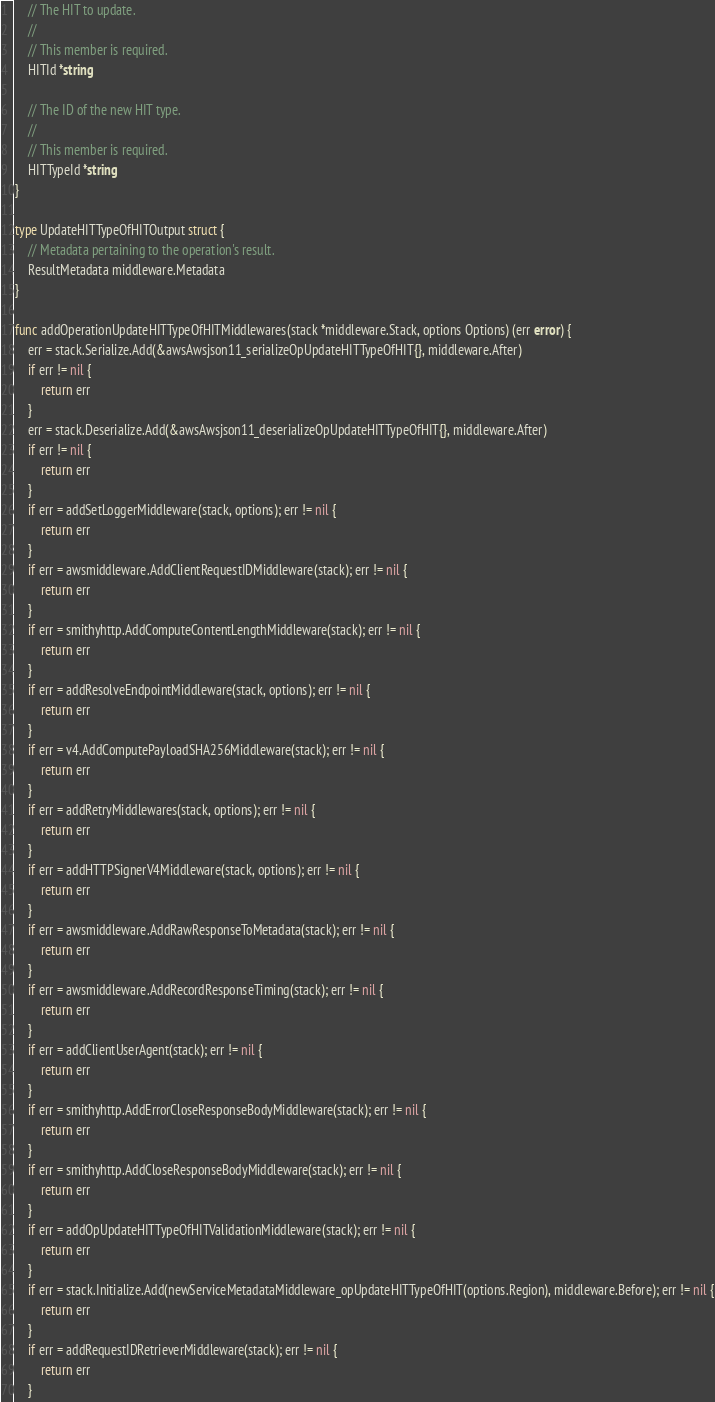Convert code to text. <code><loc_0><loc_0><loc_500><loc_500><_Go_>	// The HIT to update.
	//
	// This member is required.
	HITId *string

	// The ID of the new HIT type.
	//
	// This member is required.
	HITTypeId *string
}

type UpdateHITTypeOfHITOutput struct {
	// Metadata pertaining to the operation's result.
	ResultMetadata middleware.Metadata
}

func addOperationUpdateHITTypeOfHITMiddlewares(stack *middleware.Stack, options Options) (err error) {
	err = stack.Serialize.Add(&awsAwsjson11_serializeOpUpdateHITTypeOfHIT{}, middleware.After)
	if err != nil {
		return err
	}
	err = stack.Deserialize.Add(&awsAwsjson11_deserializeOpUpdateHITTypeOfHIT{}, middleware.After)
	if err != nil {
		return err
	}
	if err = addSetLoggerMiddleware(stack, options); err != nil {
		return err
	}
	if err = awsmiddleware.AddClientRequestIDMiddleware(stack); err != nil {
		return err
	}
	if err = smithyhttp.AddComputeContentLengthMiddleware(stack); err != nil {
		return err
	}
	if err = addResolveEndpointMiddleware(stack, options); err != nil {
		return err
	}
	if err = v4.AddComputePayloadSHA256Middleware(stack); err != nil {
		return err
	}
	if err = addRetryMiddlewares(stack, options); err != nil {
		return err
	}
	if err = addHTTPSignerV4Middleware(stack, options); err != nil {
		return err
	}
	if err = awsmiddleware.AddRawResponseToMetadata(stack); err != nil {
		return err
	}
	if err = awsmiddleware.AddRecordResponseTiming(stack); err != nil {
		return err
	}
	if err = addClientUserAgent(stack); err != nil {
		return err
	}
	if err = smithyhttp.AddErrorCloseResponseBodyMiddleware(stack); err != nil {
		return err
	}
	if err = smithyhttp.AddCloseResponseBodyMiddleware(stack); err != nil {
		return err
	}
	if err = addOpUpdateHITTypeOfHITValidationMiddleware(stack); err != nil {
		return err
	}
	if err = stack.Initialize.Add(newServiceMetadataMiddleware_opUpdateHITTypeOfHIT(options.Region), middleware.Before); err != nil {
		return err
	}
	if err = addRequestIDRetrieverMiddleware(stack); err != nil {
		return err
	}</code> 